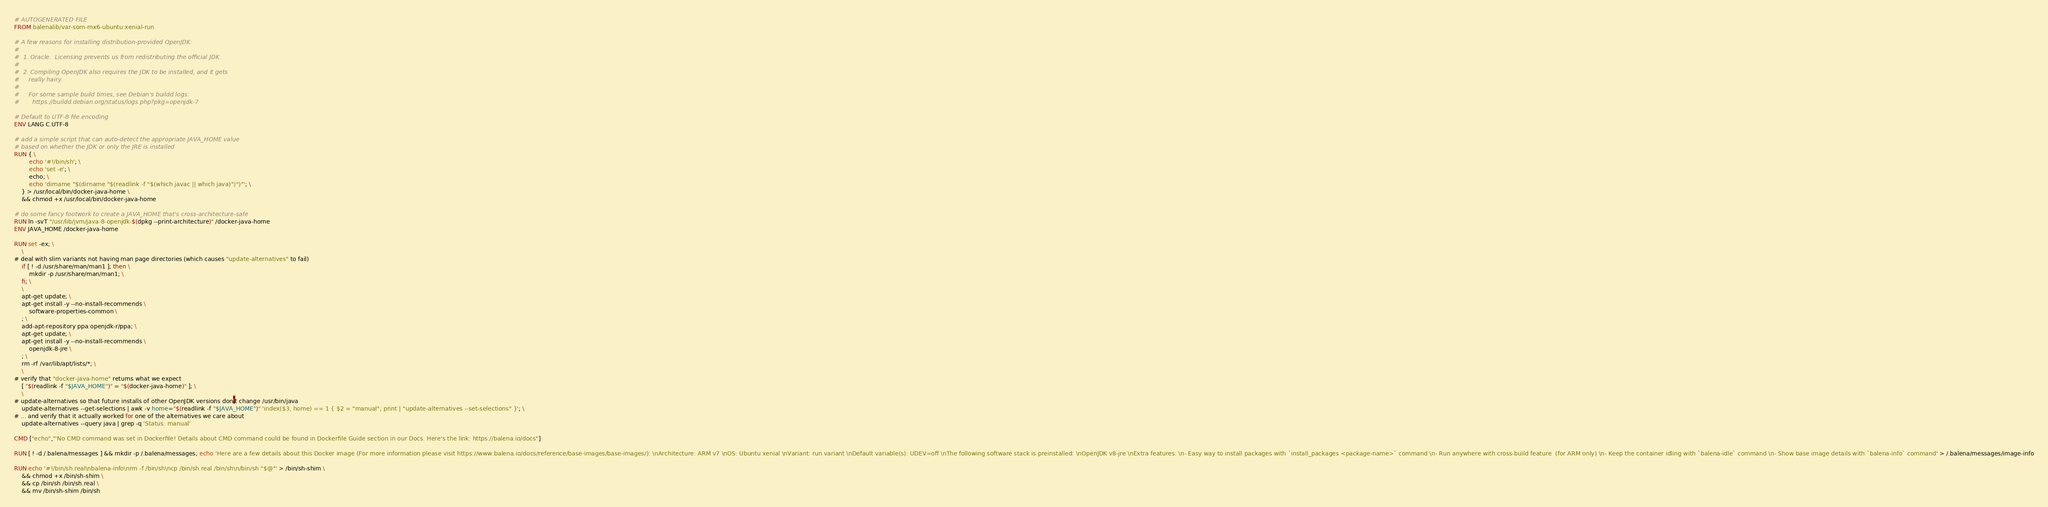<code> <loc_0><loc_0><loc_500><loc_500><_Dockerfile_># AUTOGENERATED FILE
FROM balenalib/var-som-mx6-ubuntu:xenial-run

# A few reasons for installing distribution-provided OpenJDK:
#
#  1. Oracle.  Licensing prevents us from redistributing the official JDK.
#
#  2. Compiling OpenJDK also requires the JDK to be installed, and it gets
#     really hairy.
#
#     For some sample build times, see Debian's buildd logs:
#       https://buildd.debian.org/status/logs.php?pkg=openjdk-7

# Default to UTF-8 file.encoding
ENV LANG C.UTF-8

# add a simple script that can auto-detect the appropriate JAVA_HOME value
# based on whether the JDK or only the JRE is installed
RUN { \
		echo '#!/bin/sh'; \
		echo 'set -e'; \
		echo; \
		echo 'dirname "$(dirname "$(readlink -f "$(which javac || which java)")")"'; \
	} > /usr/local/bin/docker-java-home \
	&& chmod +x /usr/local/bin/docker-java-home

# do some fancy footwork to create a JAVA_HOME that's cross-architecture-safe
RUN ln -svT "/usr/lib/jvm/java-8-openjdk-$(dpkg --print-architecture)" /docker-java-home
ENV JAVA_HOME /docker-java-home

RUN set -ex; \
	\
# deal with slim variants not having man page directories (which causes "update-alternatives" to fail)
	if [ ! -d /usr/share/man/man1 ]; then \
		mkdir -p /usr/share/man/man1; \
	fi; \
	\
	apt-get update; \
	apt-get install -y --no-install-recommends \
		software-properties-common \
	; \
	add-apt-repository ppa:openjdk-r/ppa; \
	apt-get update; \
	apt-get install -y --no-install-recommends \
		openjdk-8-jre \
	; \
	rm -rf /var/lib/apt/lists/*; \
	\
# verify that "docker-java-home" returns what we expect
	[ "$(readlink -f "$JAVA_HOME")" = "$(docker-java-home)" ]; \
	\
# update-alternatives so that future installs of other OpenJDK versions don't change /usr/bin/java
	update-alternatives --get-selections | awk -v home="$(readlink -f "$JAVA_HOME")" 'index($3, home) == 1 { $2 = "manual"; print | "update-alternatives --set-selections" }'; \
# ... and verify that it actually worked for one of the alternatives we care about
	update-alternatives --query java | grep -q 'Status: manual'

CMD ["echo","'No CMD command was set in Dockerfile! Details about CMD command could be found in Dockerfile Guide section in our Docs. Here's the link: https://balena.io/docs"]

RUN [ ! -d /.balena/messages ] && mkdir -p /.balena/messages; echo 'Here are a few details about this Docker image (For more information please visit https://www.balena.io/docs/reference/base-images/base-images/): \nArchitecture: ARM v7 \nOS: Ubuntu xenial \nVariant: run variant \nDefault variable(s): UDEV=off \nThe following software stack is preinstalled: \nOpenJDK v8-jre \nExtra features: \n- Easy way to install packages with `install_packages <package-name>` command \n- Run anywhere with cross-build feature  (for ARM only) \n- Keep the container idling with `balena-idle` command \n- Show base image details with `balena-info` command' > /.balena/messages/image-info

RUN echo '#!/bin/sh.real\nbalena-info\nrm -f /bin/sh\ncp /bin/sh.real /bin/sh\n/bin/sh "$@"' > /bin/sh-shim \
	&& chmod +x /bin/sh-shim \
	&& cp /bin/sh /bin/sh.real \
	&& mv /bin/sh-shim /bin/sh</code> 